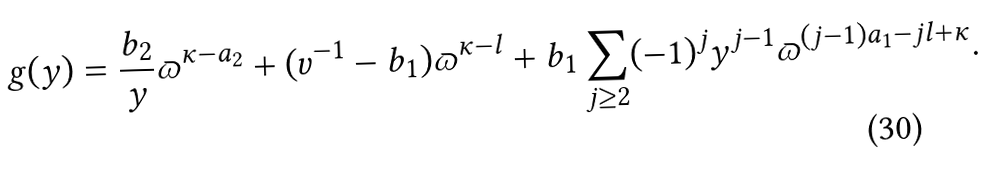Convert formula to latex. <formula><loc_0><loc_0><loc_500><loc_500>g ( y ) = \frac { b _ { 2 } } { y } \varpi ^ { \kappa - a _ { 2 } } + ( v ^ { - 1 } - b _ { 1 } ) \varpi ^ { \kappa - l } + b _ { 1 } \sum _ { j \geq 2 } ( - 1 ) ^ { j } y ^ { j - 1 } \varpi ^ { ( j - 1 ) a _ { 1 } - j l + \kappa } .</formula> 